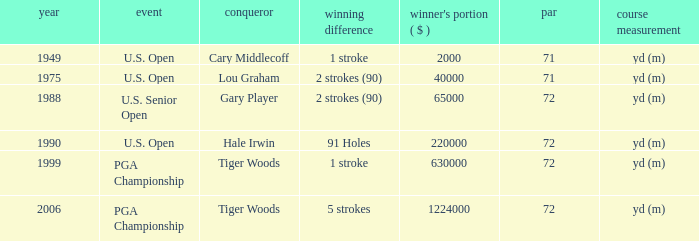When cary middlecoff is the winner how many pars are there? 1.0. 